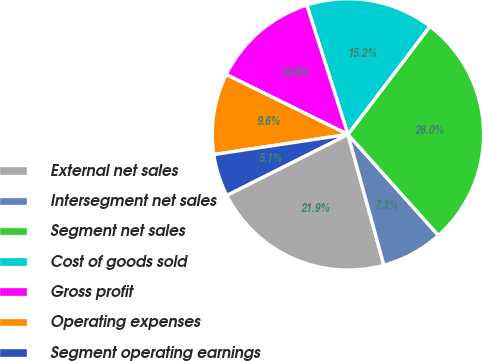Convert chart to OTSL. <chart><loc_0><loc_0><loc_500><loc_500><pie_chart><fcel>External net sales<fcel>Intersegment net sales<fcel>Segment net sales<fcel>Cost of goods sold<fcel>Gross profit<fcel>Operating expenses<fcel>Segment operating earnings<nl><fcel>21.85%<fcel>7.35%<fcel>28.05%<fcel>15.23%<fcel>12.82%<fcel>9.65%<fcel>5.05%<nl></chart> 